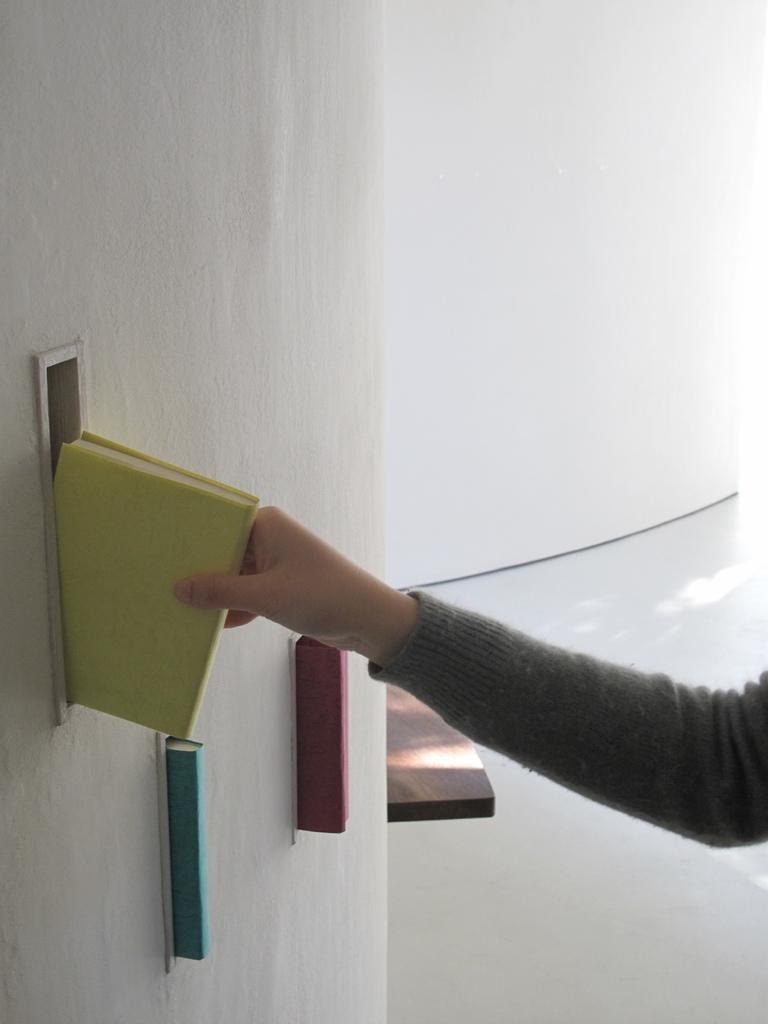How would you summarize this image in a sentence or two? In the foreground I can see a person is holding a book in hand, table and books. In the background I can see a wall. This image is taken may be in a hall. 